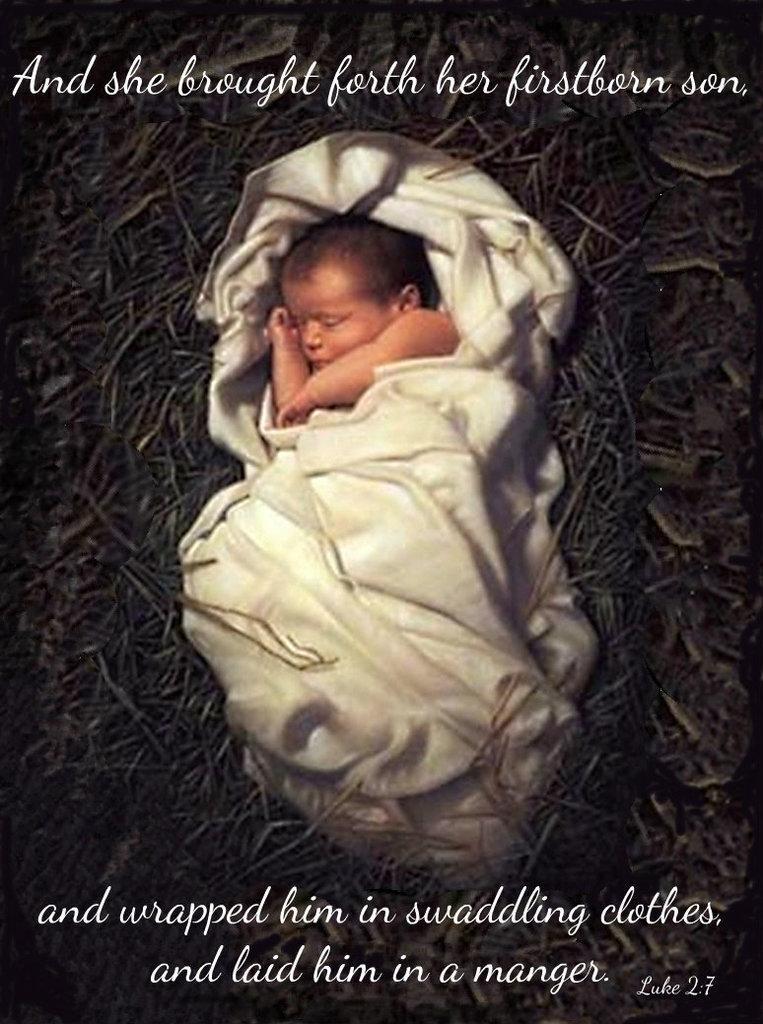In one or two sentences, can you explain what this image depicts? As we can see in the image there is a child, white color cloth and the image is little dark. 